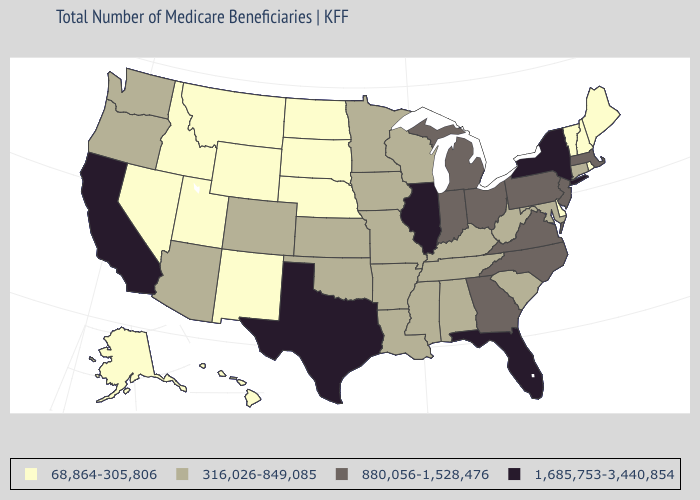Does Illinois have the highest value in the USA?
Quick response, please. Yes. Does California have a lower value than Arizona?
Keep it brief. No. Is the legend a continuous bar?
Answer briefly. No. Does California have the highest value in the West?
Answer briefly. Yes. What is the value of Kansas?
Keep it brief. 316,026-849,085. Does Arizona have the lowest value in the West?
Short answer required. No. What is the value of West Virginia?
Quick response, please. 316,026-849,085. What is the value of New York?
Quick response, please. 1,685,753-3,440,854. What is the lowest value in states that border Louisiana?
Write a very short answer. 316,026-849,085. Does California have the lowest value in the USA?
Concise answer only. No. Does Oregon have the lowest value in the West?
Concise answer only. No. Does California have the highest value in the USA?
Short answer required. Yes. What is the lowest value in the USA?
Answer briefly. 68,864-305,806. Does the first symbol in the legend represent the smallest category?
Give a very brief answer. Yes. How many symbols are there in the legend?
Give a very brief answer. 4. 